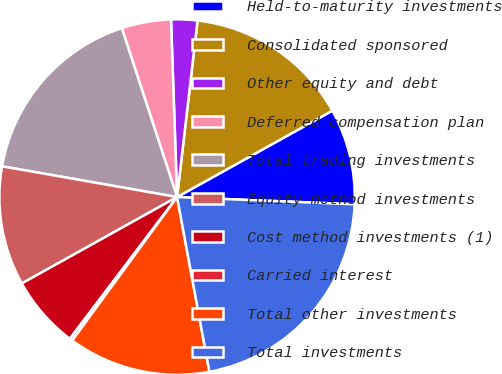Convert chart to OTSL. <chart><loc_0><loc_0><loc_500><loc_500><pie_chart><fcel>Held-to-maturity investments<fcel>Consolidated sponsored<fcel>Other equity and debt<fcel>Deferred compensation plan<fcel>Total trading investments<fcel>Equity method investments<fcel>Cost method investments (1)<fcel>Carried interest<fcel>Total other investments<fcel>Total investments<nl><fcel>8.73%<fcel>15.08%<fcel>2.38%<fcel>4.49%<fcel>17.2%<fcel>10.85%<fcel>6.61%<fcel>0.26%<fcel>12.96%<fcel>21.44%<nl></chart> 